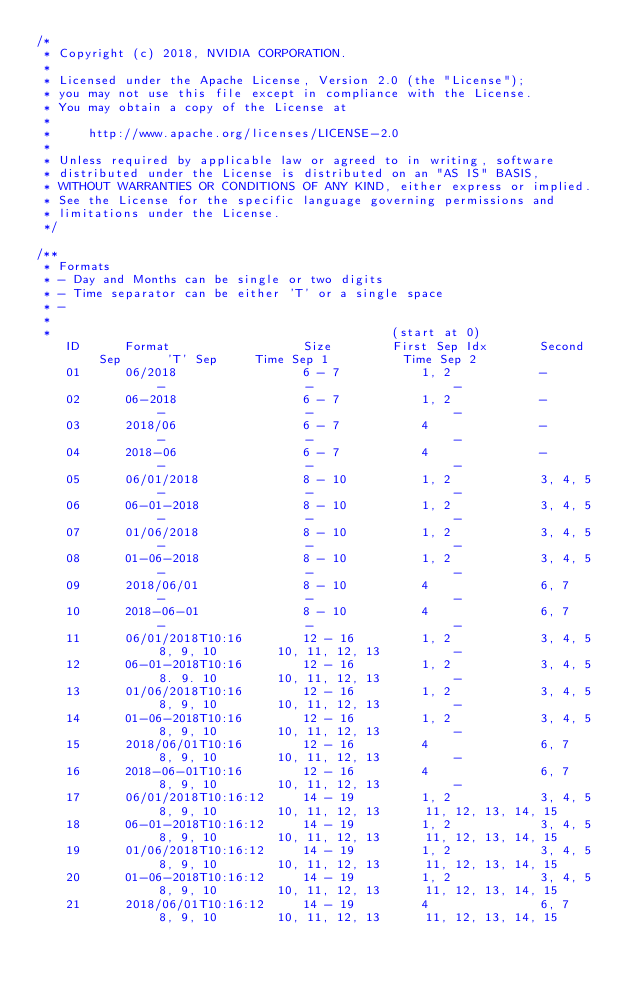Convert code to text. <code><loc_0><loc_0><loc_500><loc_500><_Cuda_>/*
 * Copyright (c) 2018, NVIDIA CORPORATION.
 *
 * Licensed under the Apache License, Version 2.0 (the "License");
 * you may not use this file except in compliance with the License.
 * You may obtain a copy of the License at
 *
 *     http://www.apache.org/licenses/LICENSE-2.0
 *
 * Unless required by applicable law or agreed to in writing, software
 * distributed under the License is distributed on an "AS IS" BASIS,
 * WITHOUT WARRANTIES OR CONDITIONS OF ANY KIND, either express or implied.
 * See the License for the specific language governing permissions and
 * limitations under the License.
 */

/**
 * Formats
 * - Day and Months can be single or two digits
 * - Time separator can be either 'T' or a single space
 * -
 *
 * 												(start at 0)
	ID		Format					Size		First Sep Idx		Second Sep		'T' Sep		Time Sep 1			Time Sep 2
 	01		06/2018					6 - 7			1, 2			-				-					-					-
    02		06-2018					6 - 7			1, 2			-				-					-					-
    03		2018/06					6 - 7			4				-				-					-					-
    04		2018-06					6 - 7			4				-				-					-					-
    05		06/01/2018				8 - 10			1, 2			3, 4, 5			-					-					-
    06		06-01-2018				8 - 10			1, 2			3, 4, 5			-					-					-
    07		01/06/2018				8 - 10			1, 2			3, 4, 5			-					-					-
    08		01-06-2018				8 - 10			1, 2			3, 4, 5			-					-					-
    09		2018/06/01				8 - 10			4				6, 7			-					-					-
    10		2018-06-01				8 - 10			4				6, 7			-					-					-
    11		06/01/2018T10:16		12 - 16			1, 2			3, 4, 5			8, 9, 10		10, 11, 12, 13			-
    12		06-01-2018T10:16		12 - 16			1, 2			3, 4, 5			8. 9. 10		10, 11, 12, 13			-
    13		01/06/2018T10:16		12 - 16			1, 2			3, 4, 5			8, 9, 10		10, 11, 12, 13			-
    14		01-06-2018T10:16		12 - 16			1, 2			3, 4, 5			8, 9, 10		10, 11, 12, 13			-
    15		2018/06/01T10:16		12 - 16			4				6, 7			8, 9, 10		10, 11, 12, 13			-
    16		2018-06-01T10:16		12 - 16			4				6, 7			8, 9, 10		10, 11, 12, 13			-
    17		06/01/2018T10:16:12		14 - 19			1, 2			3, 4, 5			8, 9, 10		10, 11, 12, 13		11, 12, 13, 14, 15
    18		06-01-2018T10:16:12		14 - 19			1, 2			3, 4, 5			8, 9, 10		10, 11, 12, 13		11, 12, 13, 14, 15
    19		01/06/2018T10:16:12		14 - 19			1, 2			3, 4, 5			8, 9, 10		10, 11, 12, 13		11, 12, 13, 14, 15
    20		01-06-2018T10:16:12		14 - 19			1, 2			3, 4, 5			8, 9, 10		10, 11, 12, 13		11, 12, 13, 14, 15
    21		2018/06/01T10:16:12		14 - 19			4				6, 7			8, 9, 10		10, 11, 12, 13		11, 12, 13, 14, 15</code> 